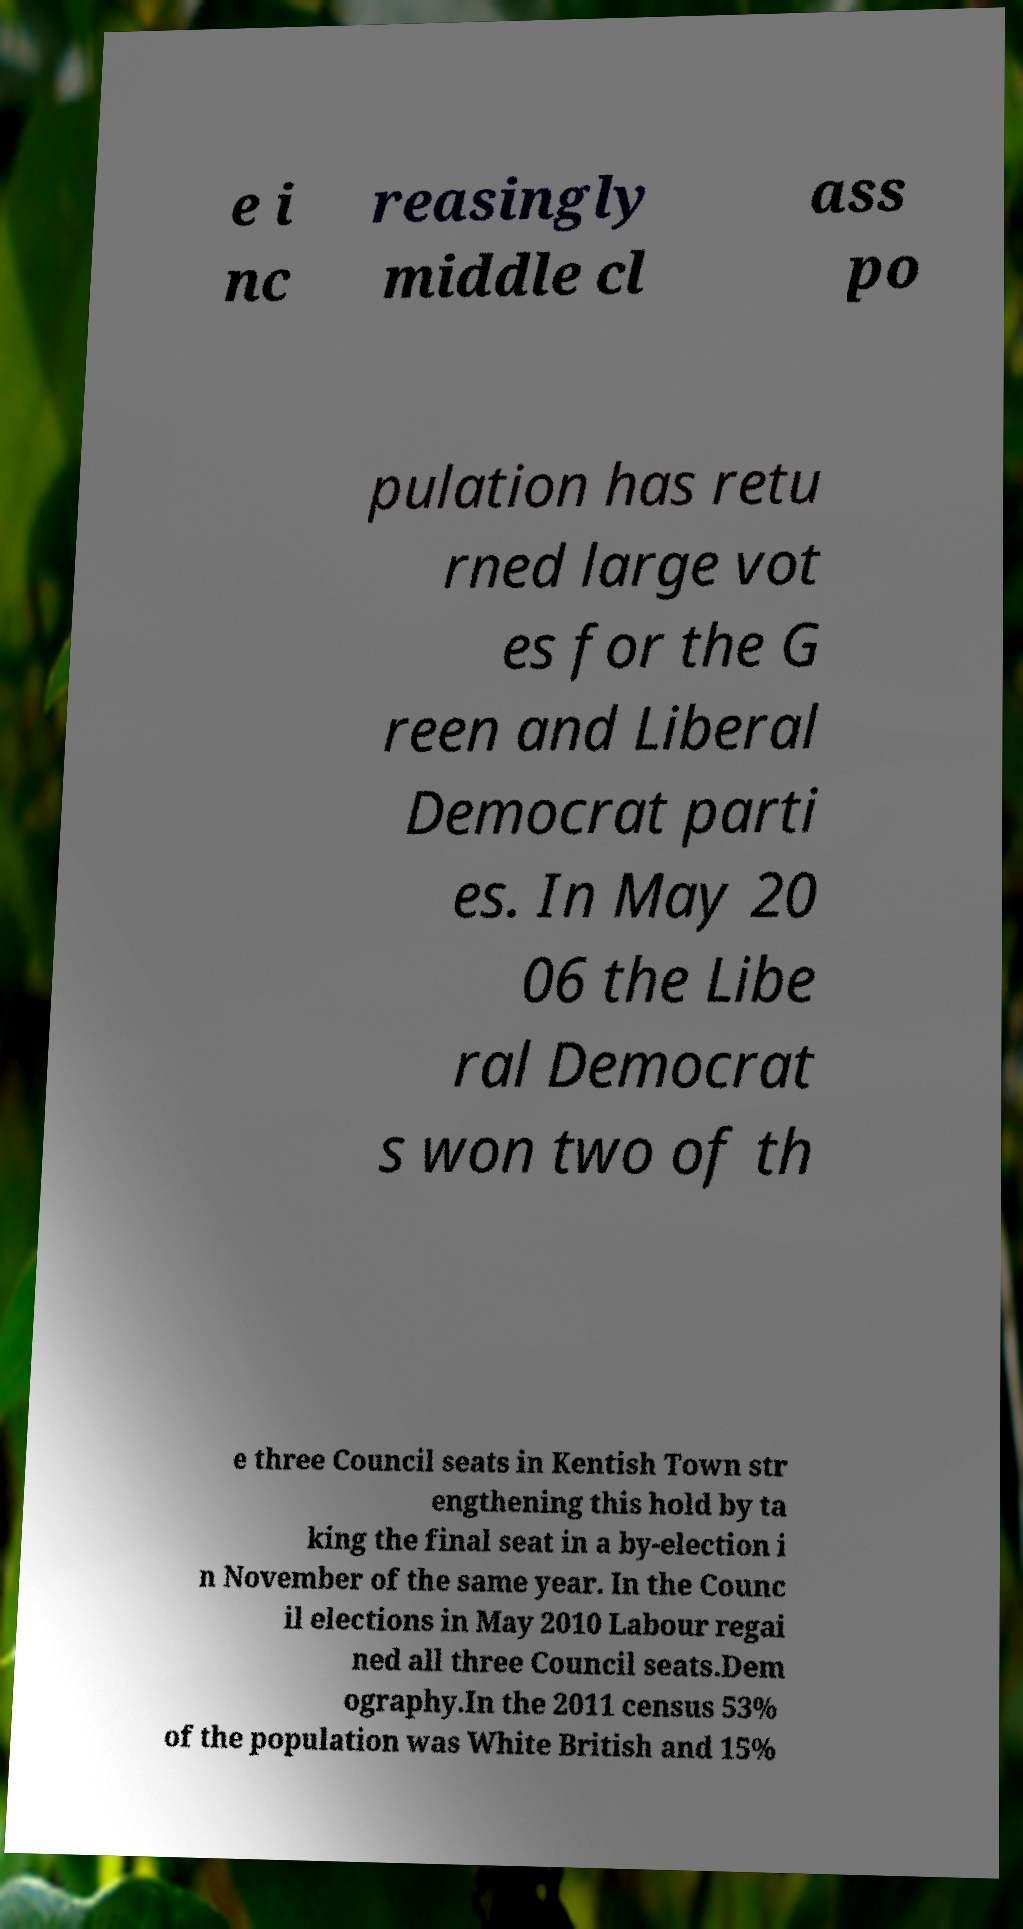What messages or text are displayed in this image? I need them in a readable, typed format. e i nc reasingly middle cl ass po pulation has retu rned large vot es for the G reen and Liberal Democrat parti es. In May 20 06 the Libe ral Democrat s won two of th e three Council seats in Kentish Town str engthening this hold by ta king the final seat in a by-election i n November of the same year. In the Counc il elections in May 2010 Labour regai ned all three Council seats.Dem ography.In the 2011 census 53% of the population was White British and 15% 